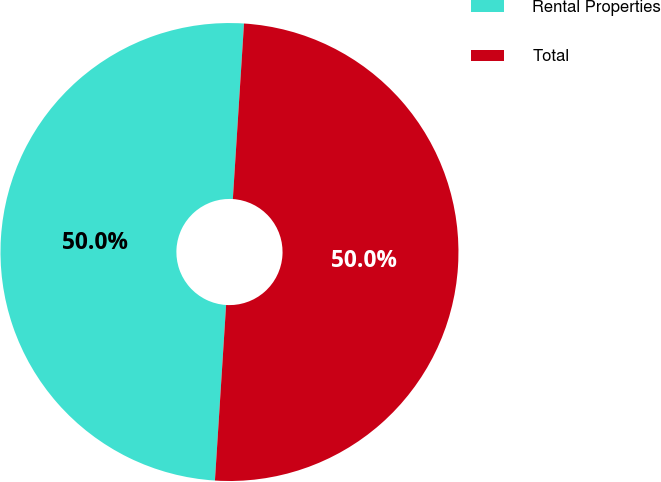Convert chart to OTSL. <chart><loc_0><loc_0><loc_500><loc_500><pie_chart><fcel>Rental Properties<fcel>Total<nl><fcel>50.0%<fcel>50.0%<nl></chart> 